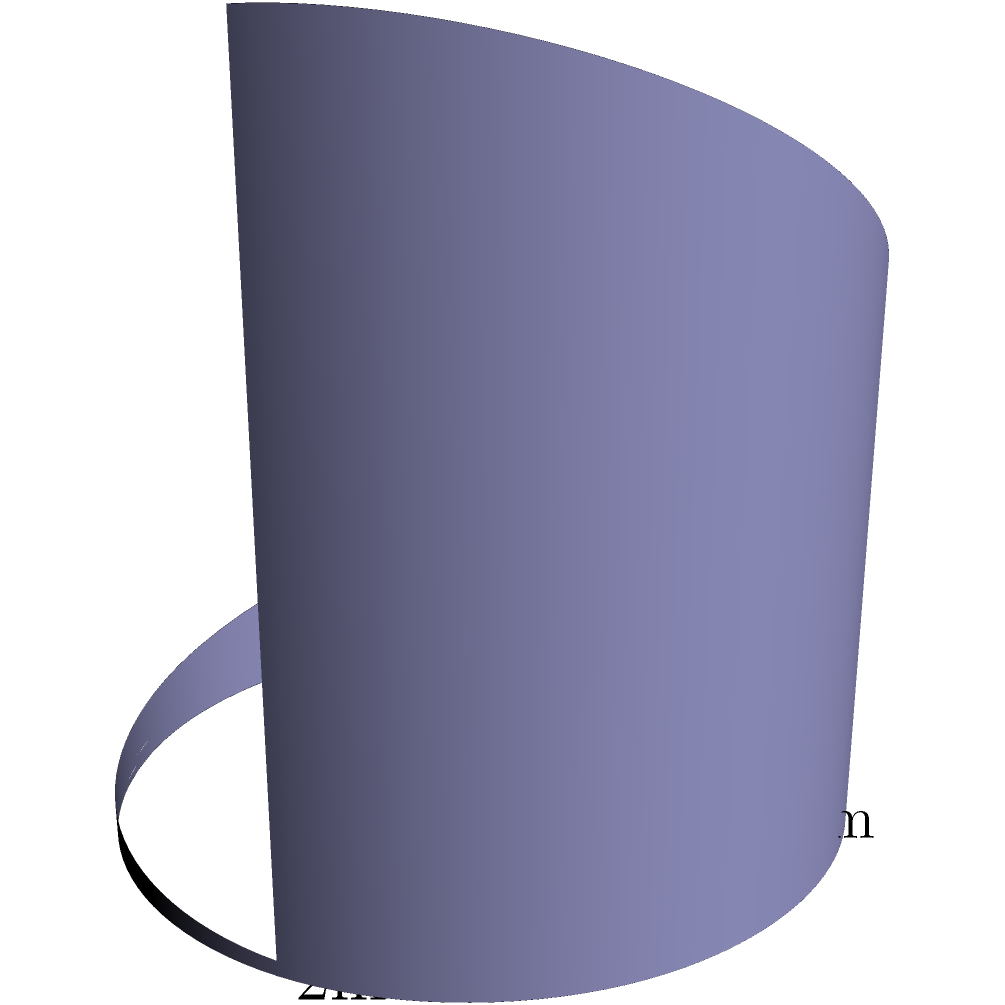A local water conservation project in South Pasadena is designing a unique rainwater collection tank. The tank's shape is represented by the function $f(x,y) = (2\cos(x), 2\sin(x), (1-\cos(y))e^{-x^2/10})$ where $0 \leq x \leq 2\pi$ and $0 \leq y \leq \pi$. Calculate the volume of water this tank can hold in cubic meters. To find the volume of this non-standard shape, we need to use a triple integral. Here's the step-by-step process:

1) The volume is given by the triple integral:
   $$V = \iiint_V dV = \int_0^{2\pi} \int_0^{\pi} \int_0^{(1-\cos(y))e^{-x^2/10}} r \, dr \, dy \, dx$$

2) First, integrate with respect to r:
   $$V = \int_0^{2\pi} \int_0^{\pi} \frac{1}{2}[(1-\cos(y))e^{-x^2/10}]^2 \, dy \, dx$$

3) Now, integrate with respect to y:
   $$V = \int_0^{2\pi} \frac{1}{2}[y - \sin(y) + \frac{1}{4}\sin(2y)]_0^{\pi} e^{-x^2/5} \, dx$$
   $$= \int_0^{2\pi} \pi e^{-x^2/5} \, dx$$

4) Finally, integrate with respect to x:
   $$V = \pi \int_0^{2\pi} e^{-x^2/5} \, dx$$
   $$= \pi \sqrt{5\pi} \text{erf}(\sqrt{2\pi/5})$$

5) Evaluating this numerically:
   $$V \approx 8.38 \text{ m}^3$$

Thus, the tank can hold approximately 8.38 cubic meters of water.
Answer: 8.38 m³ 